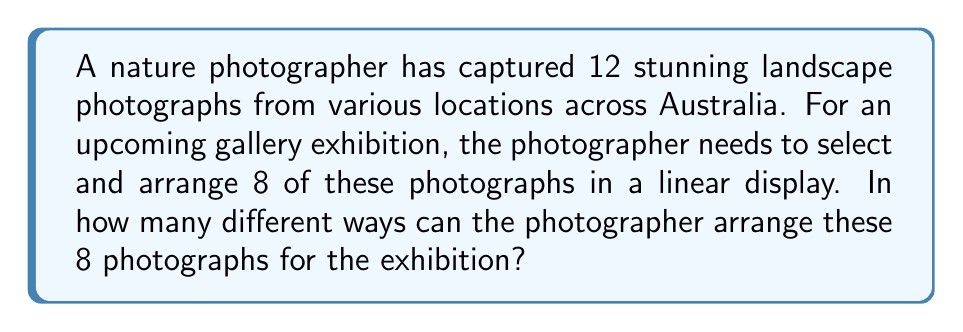Could you help me with this problem? Let's approach this step-by-step:

1) First, we need to select 8 photographs out of the 12 available. This is a combination problem.

2) After selecting the 8 photographs, we need to arrange them in a specific order. This is a permutation problem.

3) To calculate the total number of ways, we'll use the multiplication principle:
   (Number of ways to select 8 photos) × (Number of ways to arrange 8 photos)

4) The number of ways to select 8 photos out of 12 is given by the combination formula:
   $$\binom{12}{8} = \frac{12!}{8!(12-8)!} = \frac{12!}{8!4!}$$

5) The number of ways to arrange 8 photos is a straightforward permutation:
   $$P(8,8) = 8!$$

6) Now, let's multiply these together:
   $$\binom{12}{8} \times 8! = \frac{12!}{8!4!} \times 8!$$

7) The 8! cancels out in the numerator and denominator:
   $$= \frac{12!}{4!}$$

8) Calculating this:
   $$= \frac{12 \times 11 \times 10 \times 9 \times 8!}{4 \times 3 \times 2 \times 1}$$
   $$= 11,880 \times 8!$$
   $$= 11,880 \times 40,320$$
   $$= 479,001,600$$

Therefore, there are 479,001,600 different ways to arrange 8 photographs out of 12 for the exhibition.
Answer: 479,001,600 